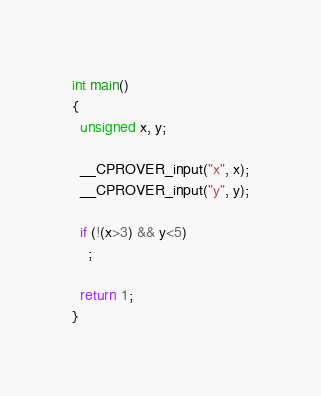Convert code to text. <code><loc_0><loc_0><loc_500><loc_500><_C_>int main()
{
  unsigned x, y;

  __CPROVER_input("x", x);
  __CPROVER_input("y", y);

  if (!(x>3) && y<5)
    ;

  return 1;
}
</code> 